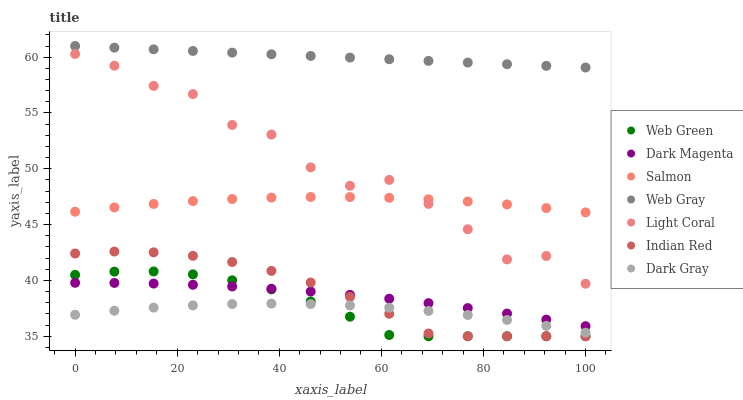Does Dark Gray have the minimum area under the curve?
Answer yes or no. Yes. Does Web Gray have the maximum area under the curve?
Answer yes or no. Yes. Does Dark Magenta have the minimum area under the curve?
Answer yes or no. No. Does Dark Magenta have the maximum area under the curve?
Answer yes or no. No. Is Web Gray the smoothest?
Answer yes or no. Yes. Is Light Coral the roughest?
Answer yes or no. Yes. Is Dark Magenta the smoothest?
Answer yes or no. No. Is Dark Magenta the roughest?
Answer yes or no. No. Does Web Green have the lowest value?
Answer yes or no. Yes. Does Dark Magenta have the lowest value?
Answer yes or no. No. Does Web Gray have the highest value?
Answer yes or no. Yes. Does Dark Magenta have the highest value?
Answer yes or no. No. Is Dark Gray less than Dark Magenta?
Answer yes or no. Yes. Is Web Gray greater than Web Green?
Answer yes or no. Yes. Does Dark Magenta intersect Indian Red?
Answer yes or no. Yes. Is Dark Magenta less than Indian Red?
Answer yes or no. No. Is Dark Magenta greater than Indian Red?
Answer yes or no. No. Does Dark Gray intersect Dark Magenta?
Answer yes or no. No. 